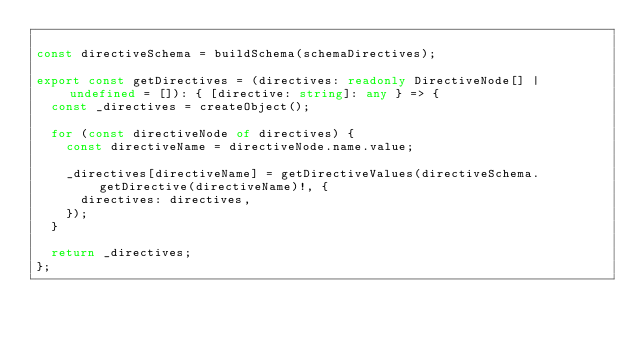Convert code to text. <code><loc_0><loc_0><loc_500><loc_500><_TypeScript_>
const directiveSchema = buildSchema(schemaDirectives);

export const getDirectives = (directives: readonly DirectiveNode[] | undefined = []): { [directive: string]: any } => {
  const _directives = createObject();

  for (const directiveNode of directives) {
    const directiveName = directiveNode.name.value;

    _directives[directiveName] = getDirectiveValues(directiveSchema.getDirective(directiveName)!, {
      directives: directives,
    });
  }

  return _directives;
};
</code> 